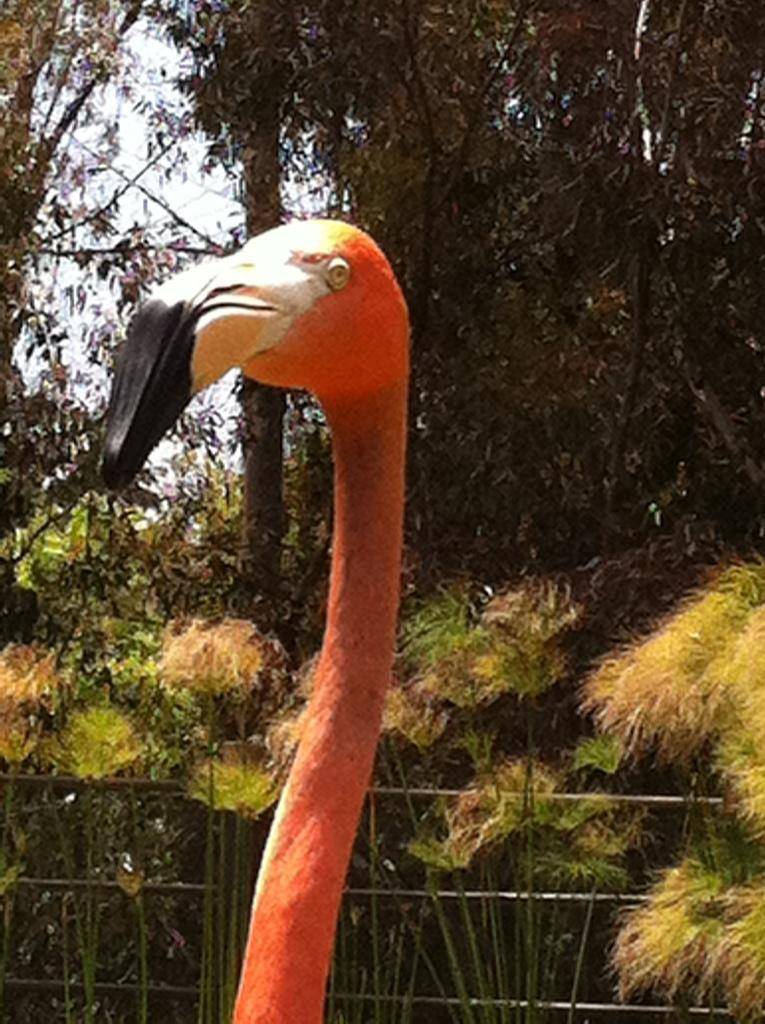What type of animal can be seen in the picture? There is a bird in the picture. Can you describe the bird's features? The bird has a long neck and a long beak. What can be seen in the background of the picture? There is a fence, plants, and trees in the background of the picture. What is the condition of the sky in the picture? The sky is clear in the picture. What type of thrill can be seen in the bird's eyes in the image? There is no indication of the bird's emotions or feelings in the image, so it cannot be determined if there is any thrill in its eyes. Can you tell me when the bird was born based on the image? The image does not provide any information about the bird's age or birth, so it cannot be determined when the bird was born. 